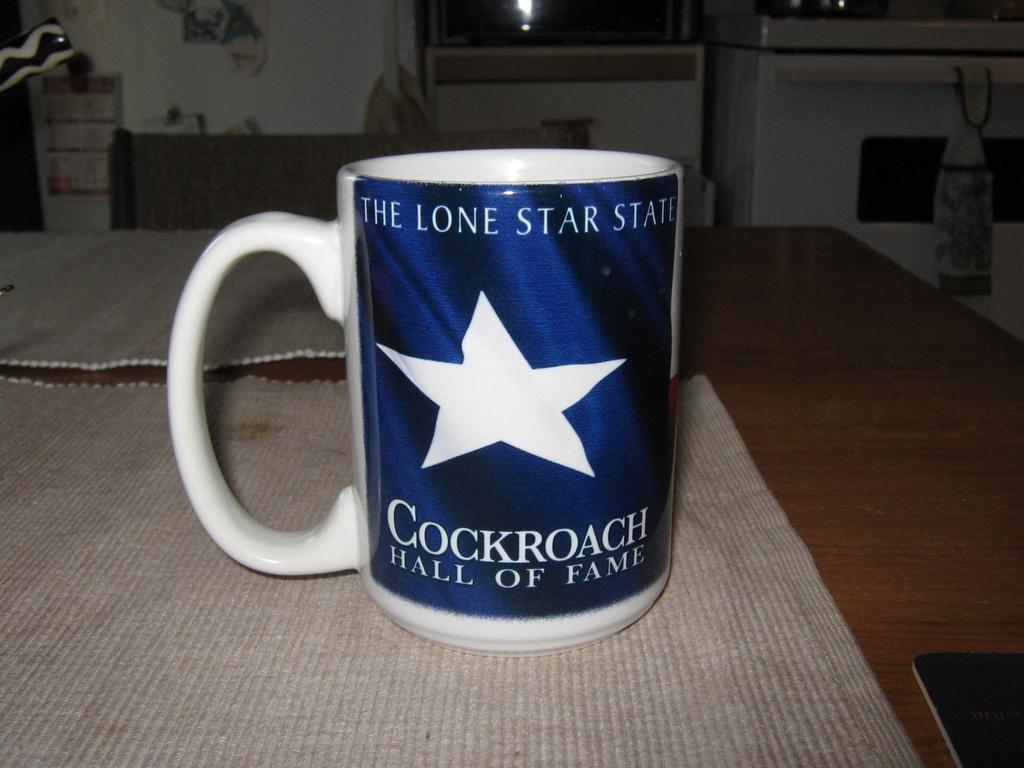<image>
Give a short and clear explanation of the subsequent image. a mug reads Cockroach Hall of fame sits on a dirty placemat 